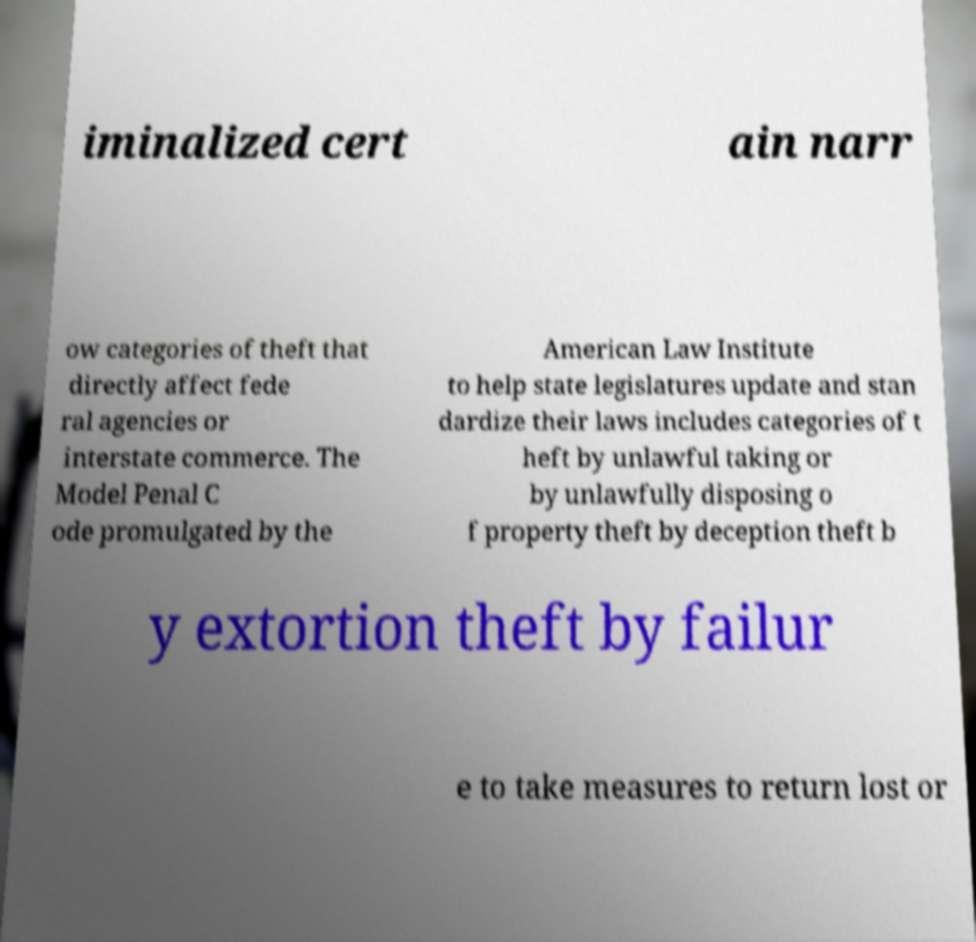Please read and relay the text visible in this image. What does it say? iminalized cert ain narr ow categories of theft that directly affect fede ral agencies or interstate commerce. The Model Penal C ode promulgated by the American Law Institute to help state legislatures update and stan dardize their laws includes categories of t heft by unlawful taking or by unlawfully disposing o f property theft by deception theft b y extortion theft by failur e to take measures to return lost or 